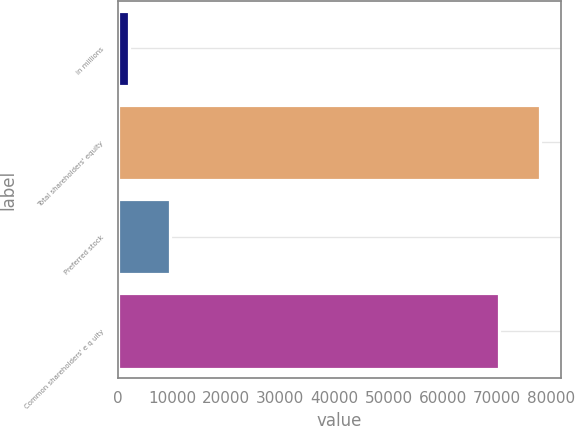Convert chart. <chart><loc_0><loc_0><loc_500><loc_500><bar_chart><fcel>in millions<fcel>Total shareholders' equity<fcel>Preferred stock<fcel>Common shareholders' e q uity<nl><fcel>2013<fcel>77995<fcel>9547<fcel>70461<nl></chart> 